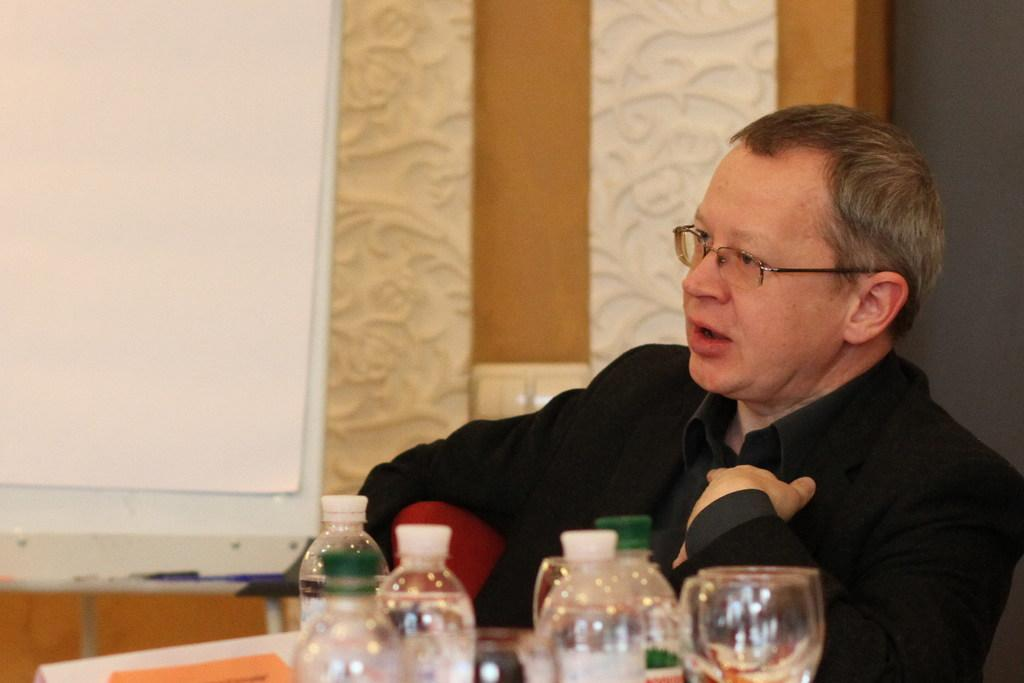Who is present in the image? There is a person in the image. What is the person wearing? The person is wearing a black suit. What is the person doing in the image? The person is sitting in a chair. What items are in front of the person? There are water bottles and glasses in front of the person. What type of whistle can be heard in the image? There is no whistle present in the image, and therefore no sound can be heard. 